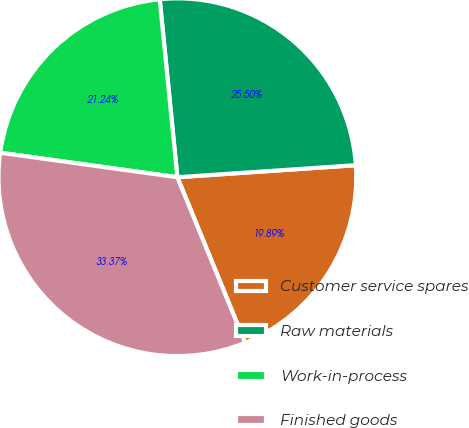<chart> <loc_0><loc_0><loc_500><loc_500><pie_chart><fcel>Customer service spares<fcel>Raw materials<fcel>Work-in-process<fcel>Finished goods<nl><fcel>19.89%<fcel>25.5%<fcel>21.24%<fcel>33.37%<nl></chart> 